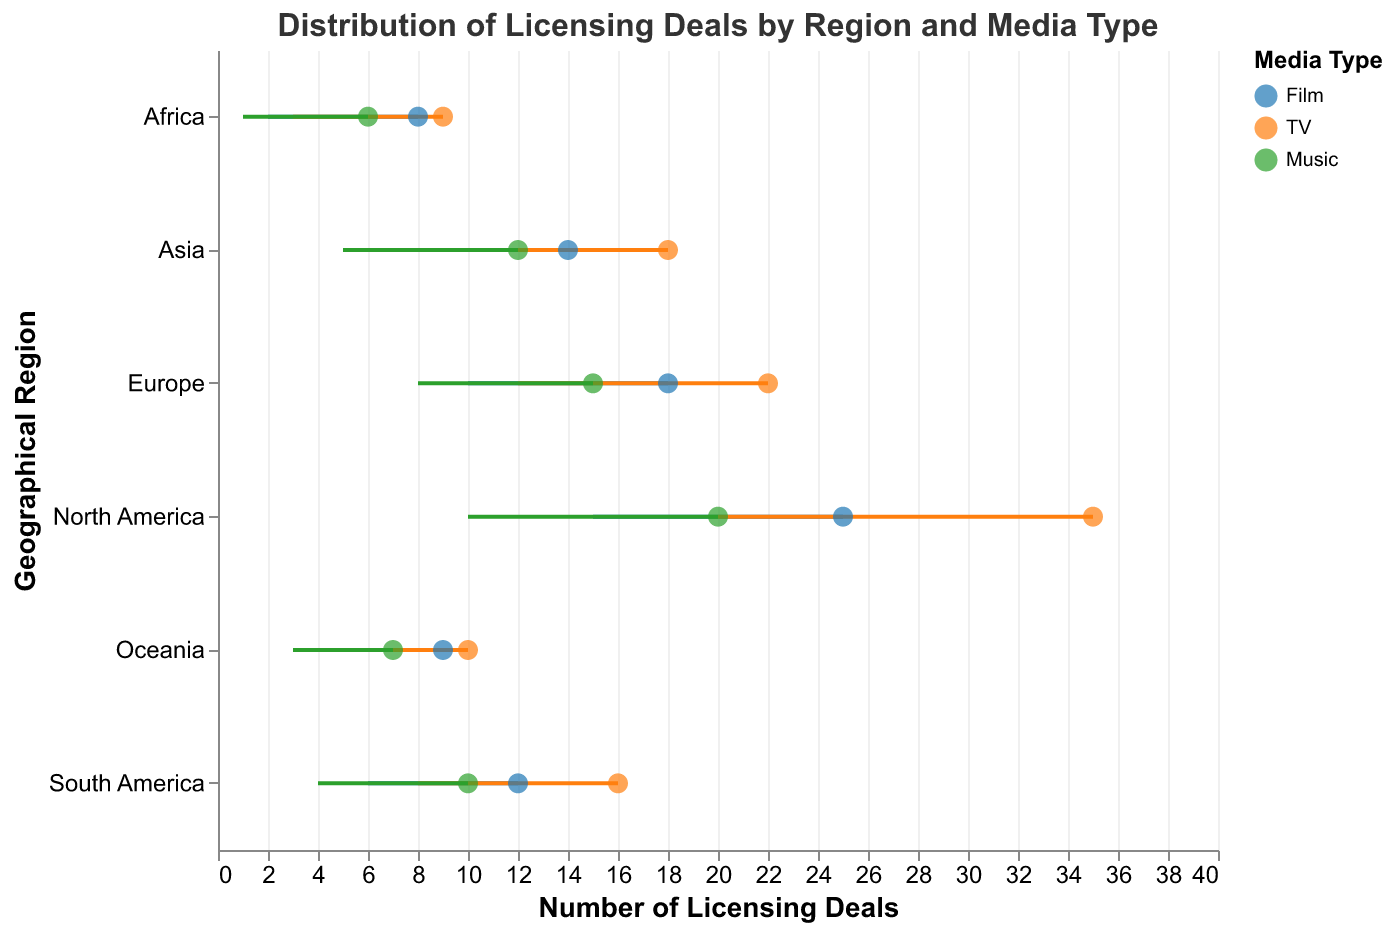What is the title of the figure? The title is usually displayed at the top of the plot. In this case, it is "Distribution of Licensing Deals by Region and Media Type" as specified in the JSON data.
Answer: Distribution of Licensing Deals by Region and Media Type How many geographical regions are represented in the plot? The y-axis represents the geographical regions, and by counting them, we find North America, Europe, Asia, South America, Africa, and Oceania, totaling 6 regions.
Answer: 6 Which media type has the widest range of licensing deals in North America? In North America, compare the ranges for Film (15-25), TV (20-35), and Music (10-20). TV has the widest range (20-35), which is 15.
Answer: TV Which geographical region has the smallest maximum licensing deals for any media type? The smallest maximum value for any media type across all regions is for Africa in Music, which is 6.
Answer: Africa What is the average minimum licensing deals for TV in all regions? To calculate the average:
- North America: 20
- Europe: 12
- Asia: 10
- South America: 8
- Africa: 3
- Oceania: 5
Sum = 20 + 12 + 10 + 8 + 3 + 5 = 58
Average = 58/6 = 9.67
Answer: 9.67 Compare the maximum licensing deals for TV and Film in Asia. Which has more? In Asia, TV has a maximum of 18 licensing deals, and Film has a maximum of 14. Therefore, TV has more.
Answer: TV What is the difference between the maximum licensing deals for Music in North America and Oceania? North America Music max is 20 and Oceania Music max is 7. 
Difference = 20 - 7 = 13
Answer: 13 Which region has the highest range of licensing deals for any media type? The highest range can be calculated and compared for each media type in all regions. TV in North America (20-35) has the highest range of 15 deals.
Answer: North America (TV) What is the median minimum licensing deals value for Film across all regions? The minimum licensing deals for Film across all regions:
- North America: 15
- Europe: 10
- Asia: 7
- South America: 6
- Africa: 2
- Oceania: 4
To find the median:
Order: 2, 4, 6, 7, 10, 15
Median = (6 + 7) / 2 = 6.5
Answer: 6.5 Which region-media combination has both the minimum and maximum licensing deals within the same range? Look for any regions and media types where min and max are the same. No region-media combination has both min and max within the same range; thus, this condition does not exist.
Answer: None 